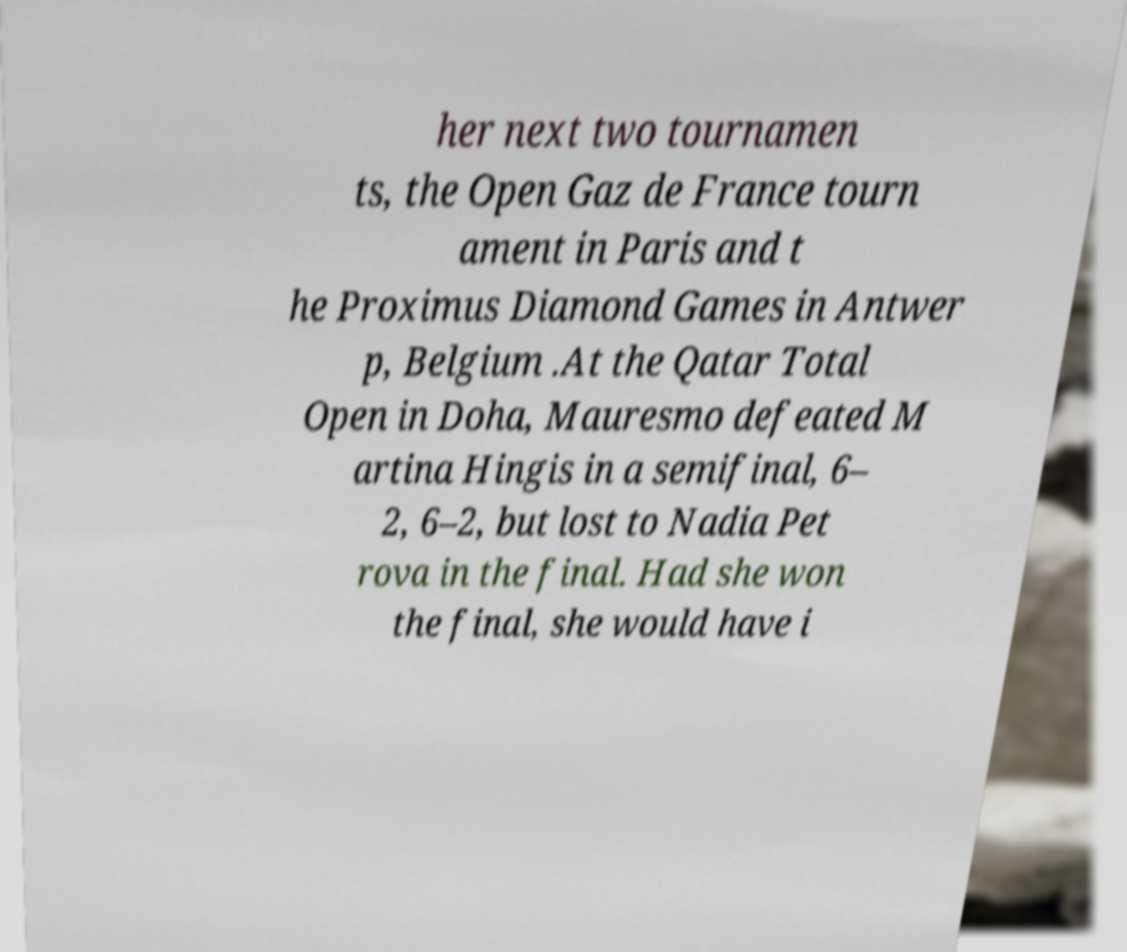What messages or text are displayed in this image? I need them in a readable, typed format. her next two tournamen ts, the Open Gaz de France tourn ament in Paris and t he Proximus Diamond Games in Antwer p, Belgium .At the Qatar Total Open in Doha, Mauresmo defeated M artina Hingis in a semifinal, 6– 2, 6–2, but lost to Nadia Pet rova in the final. Had she won the final, she would have i 